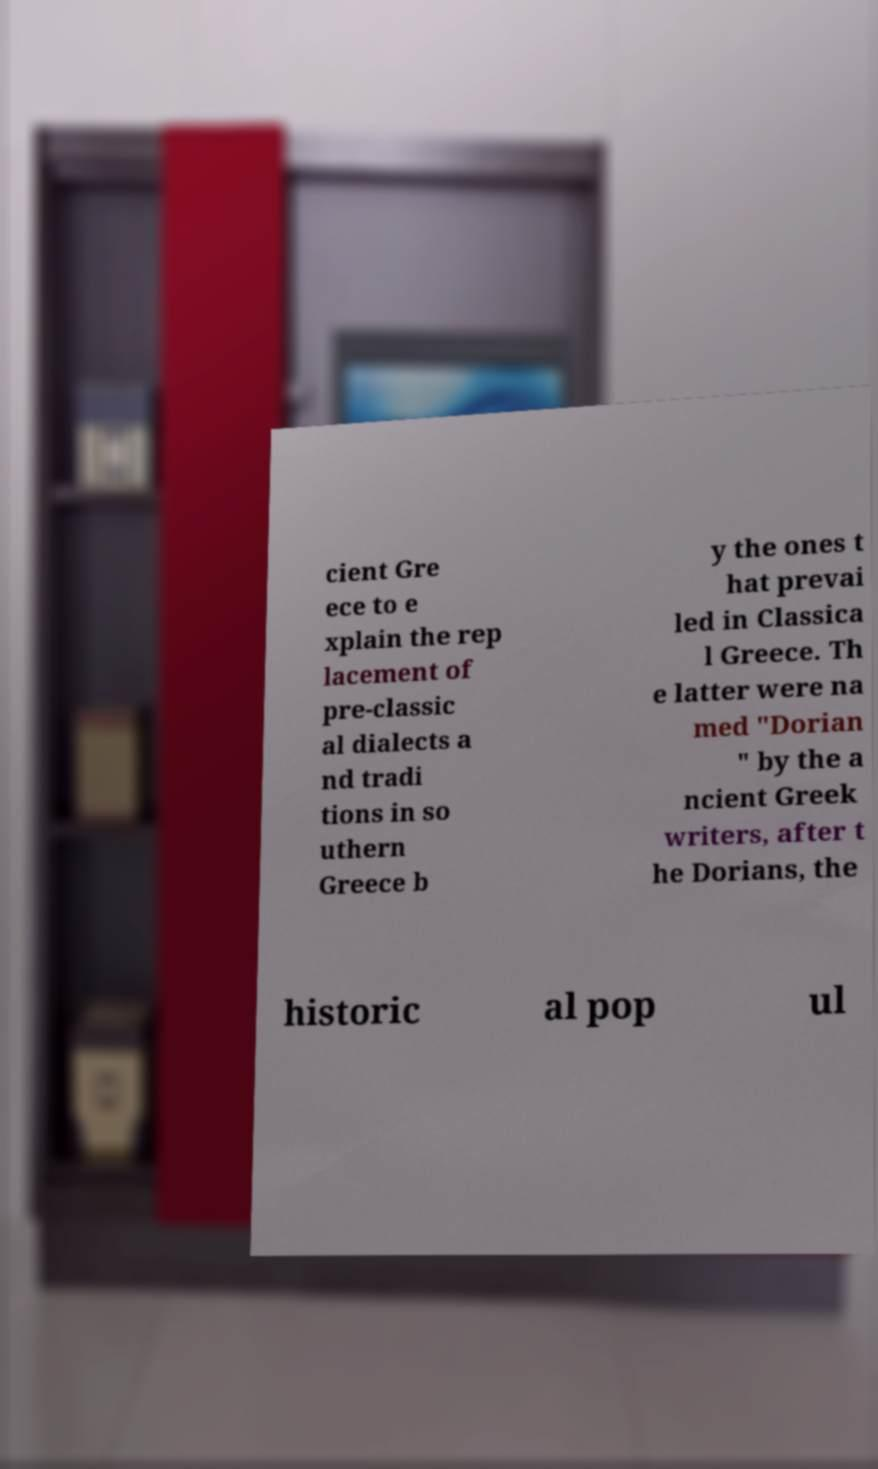For documentation purposes, I need the text within this image transcribed. Could you provide that? cient Gre ece to e xplain the rep lacement of pre-classic al dialects a nd tradi tions in so uthern Greece b y the ones t hat prevai led in Classica l Greece. Th e latter were na med "Dorian " by the a ncient Greek writers, after t he Dorians, the historic al pop ul 